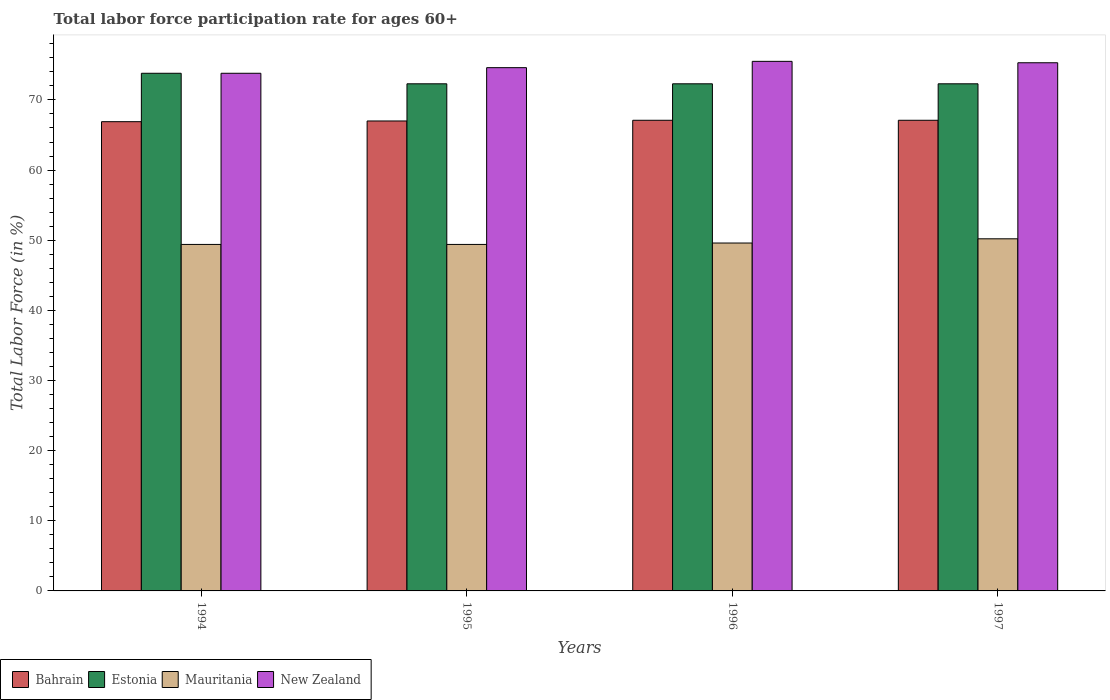How many groups of bars are there?
Your answer should be very brief. 4. In how many cases, is the number of bars for a given year not equal to the number of legend labels?
Make the answer very short. 0. Across all years, what is the maximum labor force participation rate in Mauritania?
Make the answer very short. 50.2. Across all years, what is the minimum labor force participation rate in Bahrain?
Your answer should be very brief. 66.9. In which year was the labor force participation rate in Estonia minimum?
Keep it short and to the point. 1995. What is the total labor force participation rate in Estonia in the graph?
Offer a very short reply. 290.7. What is the difference between the labor force participation rate in New Zealand in 1994 and that in 1996?
Provide a short and direct response. -1.7. What is the difference between the labor force participation rate in Estonia in 1997 and the labor force participation rate in New Zealand in 1996?
Make the answer very short. -3.2. What is the average labor force participation rate in Bahrain per year?
Provide a short and direct response. 67.02. In the year 1996, what is the difference between the labor force participation rate in Mauritania and labor force participation rate in New Zealand?
Give a very brief answer. -25.9. What is the ratio of the labor force participation rate in New Zealand in 1996 to that in 1997?
Offer a terse response. 1. What is the difference between the highest and the lowest labor force participation rate in Mauritania?
Give a very brief answer. 0.8. Is the sum of the labor force participation rate in Estonia in 1996 and 1997 greater than the maximum labor force participation rate in Mauritania across all years?
Offer a terse response. Yes. Is it the case that in every year, the sum of the labor force participation rate in Mauritania and labor force participation rate in Estonia is greater than the sum of labor force participation rate in Bahrain and labor force participation rate in New Zealand?
Give a very brief answer. No. What does the 3rd bar from the left in 1996 represents?
Give a very brief answer. Mauritania. What does the 3rd bar from the right in 1996 represents?
Your answer should be compact. Estonia. Is it the case that in every year, the sum of the labor force participation rate in Estonia and labor force participation rate in Bahrain is greater than the labor force participation rate in New Zealand?
Your response must be concise. Yes. How many bars are there?
Keep it short and to the point. 16. Are all the bars in the graph horizontal?
Your response must be concise. No. How many years are there in the graph?
Offer a terse response. 4. What is the difference between two consecutive major ticks on the Y-axis?
Provide a short and direct response. 10. What is the title of the graph?
Your response must be concise. Total labor force participation rate for ages 60+. Does "Kyrgyz Republic" appear as one of the legend labels in the graph?
Provide a succinct answer. No. What is the Total Labor Force (in %) in Bahrain in 1994?
Your answer should be very brief. 66.9. What is the Total Labor Force (in %) in Estonia in 1994?
Your answer should be very brief. 73.8. What is the Total Labor Force (in %) in Mauritania in 1994?
Your response must be concise. 49.4. What is the Total Labor Force (in %) in New Zealand in 1994?
Give a very brief answer. 73.8. What is the Total Labor Force (in %) in Estonia in 1995?
Your answer should be compact. 72.3. What is the Total Labor Force (in %) in Mauritania in 1995?
Ensure brevity in your answer.  49.4. What is the Total Labor Force (in %) in New Zealand in 1995?
Ensure brevity in your answer.  74.6. What is the Total Labor Force (in %) of Bahrain in 1996?
Your answer should be compact. 67.1. What is the Total Labor Force (in %) in Estonia in 1996?
Your answer should be very brief. 72.3. What is the Total Labor Force (in %) of Mauritania in 1996?
Offer a very short reply. 49.6. What is the Total Labor Force (in %) of New Zealand in 1996?
Keep it short and to the point. 75.5. What is the Total Labor Force (in %) in Bahrain in 1997?
Your answer should be compact. 67.1. What is the Total Labor Force (in %) of Estonia in 1997?
Offer a terse response. 72.3. What is the Total Labor Force (in %) of Mauritania in 1997?
Provide a short and direct response. 50.2. What is the Total Labor Force (in %) in New Zealand in 1997?
Make the answer very short. 75.3. Across all years, what is the maximum Total Labor Force (in %) of Bahrain?
Give a very brief answer. 67.1. Across all years, what is the maximum Total Labor Force (in %) in Estonia?
Offer a very short reply. 73.8. Across all years, what is the maximum Total Labor Force (in %) in Mauritania?
Your answer should be very brief. 50.2. Across all years, what is the maximum Total Labor Force (in %) in New Zealand?
Your answer should be very brief. 75.5. Across all years, what is the minimum Total Labor Force (in %) of Bahrain?
Give a very brief answer. 66.9. Across all years, what is the minimum Total Labor Force (in %) in Estonia?
Keep it short and to the point. 72.3. Across all years, what is the minimum Total Labor Force (in %) in Mauritania?
Give a very brief answer. 49.4. Across all years, what is the minimum Total Labor Force (in %) of New Zealand?
Your answer should be very brief. 73.8. What is the total Total Labor Force (in %) of Bahrain in the graph?
Give a very brief answer. 268.1. What is the total Total Labor Force (in %) of Estonia in the graph?
Provide a short and direct response. 290.7. What is the total Total Labor Force (in %) in Mauritania in the graph?
Your answer should be compact. 198.6. What is the total Total Labor Force (in %) of New Zealand in the graph?
Provide a short and direct response. 299.2. What is the difference between the Total Labor Force (in %) of Bahrain in 1994 and that in 1995?
Provide a short and direct response. -0.1. What is the difference between the Total Labor Force (in %) in Mauritania in 1994 and that in 1995?
Keep it short and to the point. 0. What is the difference between the Total Labor Force (in %) in New Zealand in 1994 and that in 1995?
Provide a short and direct response. -0.8. What is the difference between the Total Labor Force (in %) in Bahrain in 1994 and that in 1996?
Provide a succinct answer. -0.2. What is the difference between the Total Labor Force (in %) in Estonia in 1994 and that in 1997?
Make the answer very short. 1.5. What is the difference between the Total Labor Force (in %) in Mauritania in 1994 and that in 1997?
Your answer should be very brief. -0.8. What is the difference between the Total Labor Force (in %) in New Zealand in 1994 and that in 1997?
Provide a short and direct response. -1.5. What is the difference between the Total Labor Force (in %) of Mauritania in 1995 and that in 1996?
Your answer should be very brief. -0.2. What is the difference between the Total Labor Force (in %) in Bahrain in 1995 and that in 1997?
Give a very brief answer. -0.1. What is the difference between the Total Labor Force (in %) in Estonia in 1995 and that in 1997?
Your response must be concise. 0. What is the difference between the Total Labor Force (in %) of Bahrain in 1996 and that in 1997?
Your response must be concise. 0. What is the difference between the Total Labor Force (in %) in Estonia in 1996 and that in 1997?
Your response must be concise. 0. What is the difference between the Total Labor Force (in %) in Mauritania in 1996 and that in 1997?
Provide a succinct answer. -0.6. What is the difference between the Total Labor Force (in %) of Bahrain in 1994 and the Total Labor Force (in %) of Estonia in 1995?
Your response must be concise. -5.4. What is the difference between the Total Labor Force (in %) of Estonia in 1994 and the Total Labor Force (in %) of Mauritania in 1995?
Keep it short and to the point. 24.4. What is the difference between the Total Labor Force (in %) of Mauritania in 1994 and the Total Labor Force (in %) of New Zealand in 1995?
Provide a succinct answer. -25.2. What is the difference between the Total Labor Force (in %) in Estonia in 1994 and the Total Labor Force (in %) in Mauritania in 1996?
Offer a very short reply. 24.2. What is the difference between the Total Labor Force (in %) of Mauritania in 1994 and the Total Labor Force (in %) of New Zealand in 1996?
Offer a terse response. -26.1. What is the difference between the Total Labor Force (in %) of Bahrain in 1994 and the Total Labor Force (in %) of Estonia in 1997?
Your answer should be compact. -5.4. What is the difference between the Total Labor Force (in %) of Bahrain in 1994 and the Total Labor Force (in %) of Mauritania in 1997?
Provide a short and direct response. 16.7. What is the difference between the Total Labor Force (in %) of Bahrain in 1994 and the Total Labor Force (in %) of New Zealand in 1997?
Give a very brief answer. -8.4. What is the difference between the Total Labor Force (in %) in Estonia in 1994 and the Total Labor Force (in %) in Mauritania in 1997?
Ensure brevity in your answer.  23.6. What is the difference between the Total Labor Force (in %) of Estonia in 1994 and the Total Labor Force (in %) of New Zealand in 1997?
Provide a short and direct response. -1.5. What is the difference between the Total Labor Force (in %) of Mauritania in 1994 and the Total Labor Force (in %) of New Zealand in 1997?
Your answer should be compact. -25.9. What is the difference between the Total Labor Force (in %) of Bahrain in 1995 and the Total Labor Force (in %) of Mauritania in 1996?
Your answer should be compact. 17.4. What is the difference between the Total Labor Force (in %) of Bahrain in 1995 and the Total Labor Force (in %) of New Zealand in 1996?
Your answer should be very brief. -8.5. What is the difference between the Total Labor Force (in %) of Estonia in 1995 and the Total Labor Force (in %) of Mauritania in 1996?
Make the answer very short. 22.7. What is the difference between the Total Labor Force (in %) in Mauritania in 1995 and the Total Labor Force (in %) in New Zealand in 1996?
Your answer should be compact. -26.1. What is the difference between the Total Labor Force (in %) in Bahrain in 1995 and the Total Labor Force (in %) in Estonia in 1997?
Give a very brief answer. -5.3. What is the difference between the Total Labor Force (in %) of Bahrain in 1995 and the Total Labor Force (in %) of New Zealand in 1997?
Ensure brevity in your answer.  -8.3. What is the difference between the Total Labor Force (in %) in Estonia in 1995 and the Total Labor Force (in %) in Mauritania in 1997?
Your response must be concise. 22.1. What is the difference between the Total Labor Force (in %) in Estonia in 1995 and the Total Labor Force (in %) in New Zealand in 1997?
Provide a short and direct response. -3. What is the difference between the Total Labor Force (in %) in Mauritania in 1995 and the Total Labor Force (in %) in New Zealand in 1997?
Make the answer very short. -25.9. What is the difference between the Total Labor Force (in %) in Bahrain in 1996 and the Total Labor Force (in %) in New Zealand in 1997?
Ensure brevity in your answer.  -8.2. What is the difference between the Total Labor Force (in %) of Estonia in 1996 and the Total Labor Force (in %) of Mauritania in 1997?
Offer a very short reply. 22.1. What is the difference between the Total Labor Force (in %) of Estonia in 1996 and the Total Labor Force (in %) of New Zealand in 1997?
Provide a short and direct response. -3. What is the difference between the Total Labor Force (in %) in Mauritania in 1996 and the Total Labor Force (in %) in New Zealand in 1997?
Provide a short and direct response. -25.7. What is the average Total Labor Force (in %) of Bahrain per year?
Keep it short and to the point. 67.03. What is the average Total Labor Force (in %) in Estonia per year?
Offer a very short reply. 72.67. What is the average Total Labor Force (in %) in Mauritania per year?
Your answer should be very brief. 49.65. What is the average Total Labor Force (in %) in New Zealand per year?
Give a very brief answer. 74.8. In the year 1994, what is the difference between the Total Labor Force (in %) in Estonia and Total Labor Force (in %) in Mauritania?
Offer a very short reply. 24.4. In the year 1994, what is the difference between the Total Labor Force (in %) in Estonia and Total Labor Force (in %) in New Zealand?
Offer a very short reply. 0. In the year 1994, what is the difference between the Total Labor Force (in %) of Mauritania and Total Labor Force (in %) of New Zealand?
Provide a succinct answer. -24.4. In the year 1995, what is the difference between the Total Labor Force (in %) of Estonia and Total Labor Force (in %) of Mauritania?
Provide a short and direct response. 22.9. In the year 1995, what is the difference between the Total Labor Force (in %) of Estonia and Total Labor Force (in %) of New Zealand?
Ensure brevity in your answer.  -2.3. In the year 1995, what is the difference between the Total Labor Force (in %) in Mauritania and Total Labor Force (in %) in New Zealand?
Provide a succinct answer. -25.2. In the year 1996, what is the difference between the Total Labor Force (in %) of Bahrain and Total Labor Force (in %) of Mauritania?
Your answer should be compact. 17.5. In the year 1996, what is the difference between the Total Labor Force (in %) in Bahrain and Total Labor Force (in %) in New Zealand?
Give a very brief answer. -8.4. In the year 1996, what is the difference between the Total Labor Force (in %) in Estonia and Total Labor Force (in %) in Mauritania?
Make the answer very short. 22.7. In the year 1996, what is the difference between the Total Labor Force (in %) in Estonia and Total Labor Force (in %) in New Zealand?
Your answer should be very brief. -3.2. In the year 1996, what is the difference between the Total Labor Force (in %) of Mauritania and Total Labor Force (in %) of New Zealand?
Offer a terse response. -25.9. In the year 1997, what is the difference between the Total Labor Force (in %) of Bahrain and Total Labor Force (in %) of Estonia?
Ensure brevity in your answer.  -5.2. In the year 1997, what is the difference between the Total Labor Force (in %) in Bahrain and Total Labor Force (in %) in Mauritania?
Offer a very short reply. 16.9. In the year 1997, what is the difference between the Total Labor Force (in %) of Estonia and Total Labor Force (in %) of Mauritania?
Offer a terse response. 22.1. In the year 1997, what is the difference between the Total Labor Force (in %) of Mauritania and Total Labor Force (in %) of New Zealand?
Ensure brevity in your answer.  -25.1. What is the ratio of the Total Labor Force (in %) in Bahrain in 1994 to that in 1995?
Your answer should be very brief. 1. What is the ratio of the Total Labor Force (in %) in Estonia in 1994 to that in 1995?
Keep it short and to the point. 1.02. What is the ratio of the Total Labor Force (in %) in New Zealand in 1994 to that in 1995?
Keep it short and to the point. 0.99. What is the ratio of the Total Labor Force (in %) in Bahrain in 1994 to that in 1996?
Give a very brief answer. 1. What is the ratio of the Total Labor Force (in %) of Estonia in 1994 to that in 1996?
Ensure brevity in your answer.  1.02. What is the ratio of the Total Labor Force (in %) in New Zealand in 1994 to that in 1996?
Offer a terse response. 0.98. What is the ratio of the Total Labor Force (in %) of Bahrain in 1994 to that in 1997?
Offer a terse response. 1. What is the ratio of the Total Labor Force (in %) in Estonia in 1994 to that in 1997?
Your response must be concise. 1.02. What is the ratio of the Total Labor Force (in %) in Mauritania in 1994 to that in 1997?
Make the answer very short. 0.98. What is the ratio of the Total Labor Force (in %) in New Zealand in 1994 to that in 1997?
Offer a terse response. 0.98. What is the ratio of the Total Labor Force (in %) in Bahrain in 1995 to that in 1996?
Provide a succinct answer. 1. What is the ratio of the Total Labor Force (in %) of Estonia in 1995 to that in 1996?
Offer a terse response. 1. What is the ratio of the Total Labor Force (in %) of Mauritania in 1995 to that in 1996?
Keep it short and to the point. 1. What is the ratio of the Total Labor Force (in %) in New Zealand in 1995 to that in 1996?
Offer a very short reply. 0.99. What is the ratio of the Total Labor Force (in %) of Estonia in 1995 to that in 1997?
Offer a very short reply. 1. What is the ratio of the Total Labor Force (in %) of Mauritania in 1995 to that in 1997?
Provide a short and direct response. 0.98. What is the ratio of the Total Labor Force (in %) in New Zealand in 1995 to that in 1997?
Offer a very short reply. 0.99. What is the ratio of the Total Labor Force (in %) of Mauritania in 1996 to that in 1997?
Your answer should be compact. 0.99. What is the ratio of the Total Labor Force (in %) in New Zealand in 1996 to that in 1997?
Offer a very short reply. 1. What is the difference between the highest and the second highest Total Labor Force (in %) in Estonia?
Offer a terse response. 1.5. What is the difference between the highest and the lowest Total Labor Force (in %) of Bahrain?
Keep it short and to the point. 0.2. What is the difference between the highest and the lowest Total Labor Force (in %) of Estonia?
Provide a short and direct response. 1.5. What is the difference between the highest and the lowest Total Labor Force (in %) of Mauritania?
Your response must be concise. 0.8. 